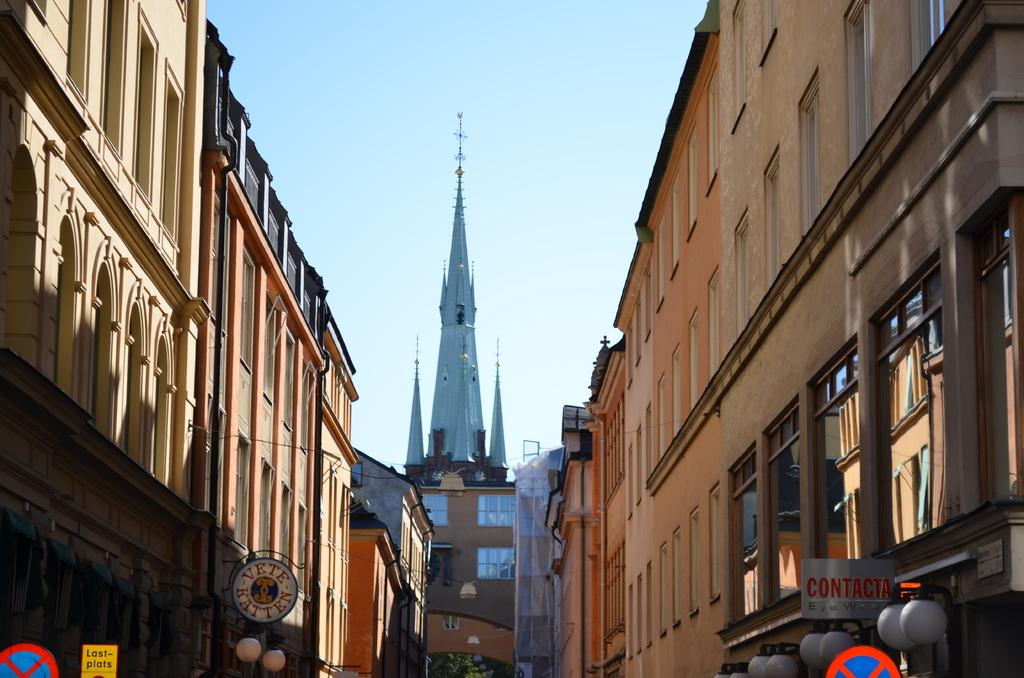What type of structures can be seen in the image? There are buildings in the image. What architectural elements are present in the image? There are walls, windows, and pipes visible in the image. What materials are used for the objects in the image? Glass objects are present in the image. What other items can be seen in the image? There are boards and a tree visible in the image. What lighting is present in the image? There are lights in the image. What can be seen in the background of the image? The sky is visible in the background of the image. Where is the umbrella placed in the image? There is no umbrella present in the image. What type of spot can be seen on the tree in the image? There are no spots visible on the tree in the image. 